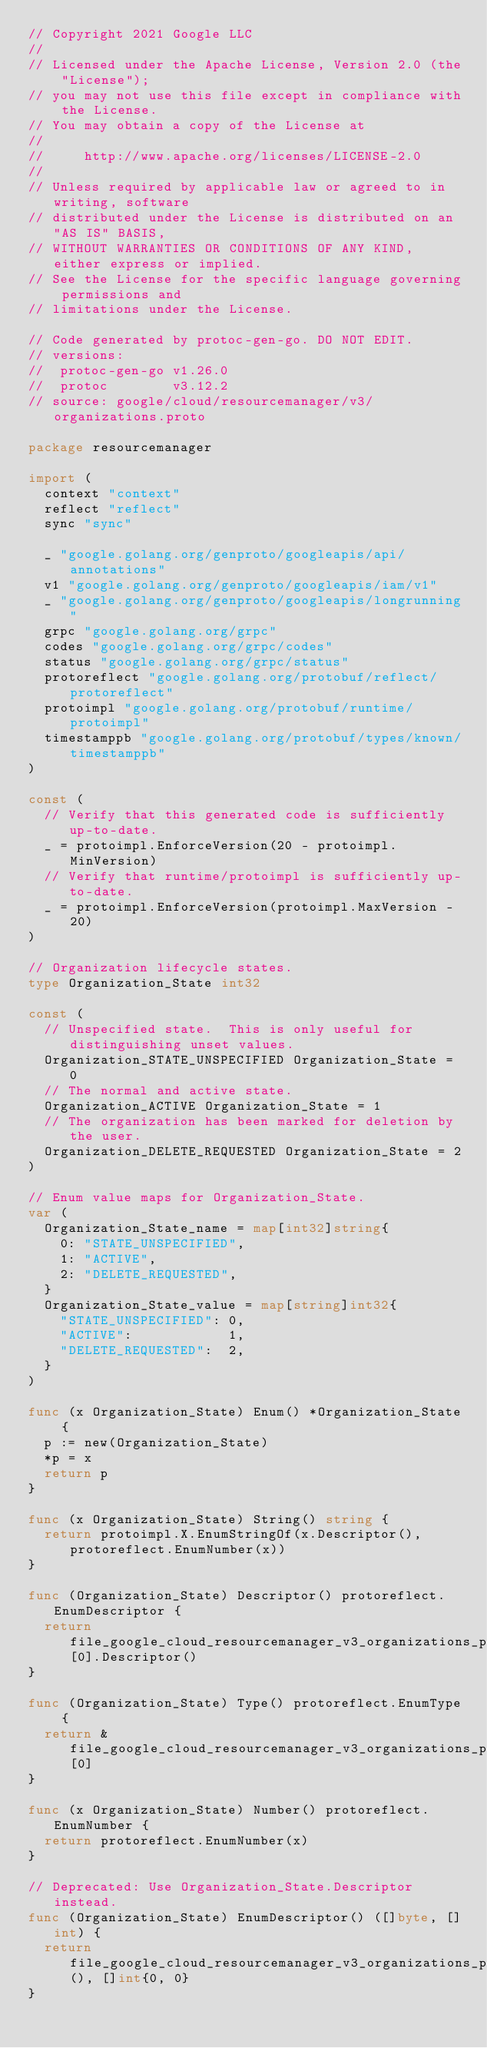<code> <loc_0><loc_0><loc_500><loc_500><_Go_>// Copyright 2021 Google LLC
//
// Licensed under the Apache License, Version 2.0 (the "License");
// you may not use this file except in compliance with the License.
// You may obtain a copy of the License at
//
//     http://www.apache.org/licenses/LICENSE-2.0
//
// Unless required by applicable law or agreed to in writing, software
// distributed under the License is distributed on an "AS IS" BASIS,
// WITHOUT WARRANTIES OR CONDITIONS OF ANY KIND, either express or implied.
// See the License for the specific language governing permissions and
// limitations under the License.

// Code generated by protoc-gen-go. DO NOT EDIT.
// versions:
// 	protoc-gen-go v1.26.0
// 	protoc        v3.12.2
// source: google/cloud/resourcemanager/v3/organizations.proto

package resourcemanager

import (
	context "context"
	reflect "reflect"
	sync "sync"

	_ "google.golang.org/genproto/googleapis/api/annotations"
	v1 "google.golang.org/genproto/googleapis/iam/v1"
	_ "google.golang.org/genproto/googleapis/longrunning"
	grpc "google.golang.org/grpc"
	codes "google.golang.org/grpc/codes"
	status "google.golang.org/grpc/status"
	protoreflect "google.golang.org/protobuf/reflect/protoreflect"
	protoimpl "google.golang.org/protobuf/runtime/protoimpl"
	timestamppb "google.golang.org/protobuf/types/known/timestamppb"
)

const (
	// Verify that this generated code is sufficiently up-to-date.
	_ = protoimpl.EnforceVersion(20 - protoimpl.MinVersion)
	// Verify that runtime/protoimpl is sufficiently up-to-date.
	_ = protoimpl.EnforceVersion(protoimpl.MaxVersion - 20)
)

// Organization lifecycle states.
type Organization_State int32

const (
	// Unspecified state.  This is only useful for distinguishing unset values.
	Organization_STATE_UNSPECIFIED Organization_State = 0
	// The normal and active state.
	Organization_ACTIVE Organization_State = 1
	// The organization has been marked for deletion by the user.
	Organization_DELETE_REQUESTED Organization_State = 2
)

// Enum value maps for Organization_State.
var (
	Organization_State_name = map[int32]string{
		0: "STATE_UNSPECIFIED",
		1: "ACTIVE",
		2: "DELETE_REQUESTED",
	}
	Organization_State_value = map[string]int32{
		"STATE_UNSPECIFIED": 0,
		"ACTIVE":            1,
		"DELETE_REQUESTED":  2,
	}
)

func (x Organization_State) Enum() *Organization_State {
	p := new(Organization_State)
	*p = x
	return p
}

func (x Organization_State) String() string {
	return protoimpl.X.EnumStringOf(x.Descriptor(), protoreflect.EnumNumber(x))
}

func (Organization_State) Descriptor() protoreflect.EnumDescriptor {
	return file_google_cloud_resourcemanager_v3_organizations_proto_enumTypes[0].Descriptor()
}

func (Organization_State) Type() protoreflect.EnumType {
	return &file_google_cloud_resourcemanager_v3_organizations_proto_enumTypes[0]
}

func (x Organization_State) Number() protoreflect.EnumNumber {
	return protoreflect.EnumNumber(x)
}

// Deprecated: Use Organization_State.Descriptor instead.
func (Organization_State) EnumDescriptor() ([]byte, []int) {
	return file_google_cloud_resourcemanager_v3_organizations_proto_rawDescGZIP(), []int{0, 0}
}
</code> 